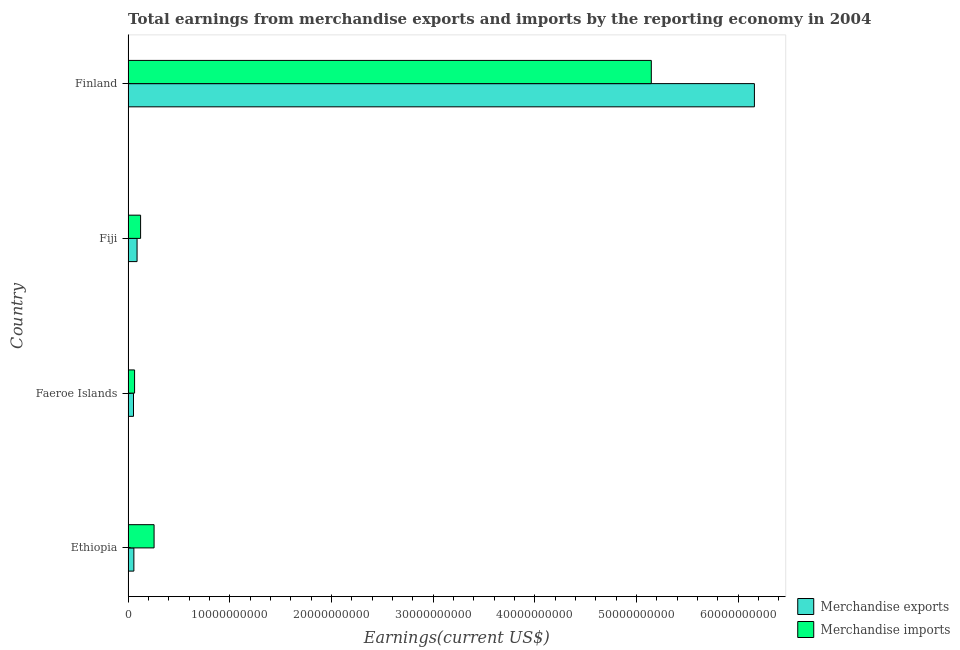How many different coloured bars are there?
Ensure brevity in your answer.  2. Are the number of bars on each tick of the Y-axis equal?
Your answer should be compact. Yes. How many bars are there on the 2nd tick from the top?
Provide a succinct answer. 2. How many bars are there on the 1st tick from the bottom?
Give a very brief answer. 2. What is the label of the 4th group of bars from the top?
Offer a very short reply. Ethiopia. In how many cases, is the number of bars for a given country not equal to the number of legend labels?
Give a very brief answer. 0. What is the earnings from merchandise exports in Faeroe Islands?
Offer a terse response. 5.34e+08. Across all countries, what is the maximum earnings from merchandise exports?
Provide a short and direct response. 6.16e+1. Across all countries, what is the minimum earnings from merchandise exports?
Make the answer very short. 5.34e+08. In which country was the earnings from merchandise exports minimum?
Offer a very short reply. Faeroe Islands. What is the total earnings from merchandise exports in the graph?
Give a very brief answer. 6.36e+1. What is the difference between the earnings from merchandise imports in Fiji and that in Finland?
Offer a terse response. -5.02e+1. What is the difference between the earnings from merchandise exports in Fiji and the earnings from merchandise imports in Faeroe Islands?
Your answer should be compact. 2.45e+08. What is the average earnings from merchandise exports per country?
Offer a very short reply. 1.59e+1. What is the difference between the earnings from merchandise exports and earnings from merchandise imports in Finland?
Ensure brevity in your answer.  1.01e+1. In how many countries, is the earnings from merchandise imports greater than 50000000000 US$?
Give a very brief answer. 1. What is the ratio of the earnings from merchandise imports in Ethiopia to that in Faeroe Islands?
Provide a succinct answer. 4. Is the earnings from merchandise imports in Ethiopia less than that in Fiji?
Your answer should be compact. No. Is the difference between the earnings from merchandise imports in Faeroe Islands and Fiji greater than the difference between the earnings from merchandise exports in Faeroe Islands and Fiji?
Offer a very short reply. No. What is the difference between the highest and the second highest earnings from merchandise imports?
Make the answer very short. 4.89e+1. What is the difference between the highest and the lowest earnings from merchandise imports?
Provide a succinct answer. 5.08e+1. What does the 2nd bar from the top in Ethiopia represents?
Provide a succinct answer. Merchandise exports. What does the 1st bar from the bottom in Finland represents?
Make the answer very short. Merchandise exports. Are all the bars in the graph horizontal?
Offer a very short reply. Yes. How many countries are there in the graph?
Offer a very short reply. 4. Are the values on the major ticks of X-axis written in scientific E-notation?
Offer a very short reply. No. Where does the legend appear in the graph?
Provide a succinct answer. Bottom right. What is the title of the graph?
Your answer should be very brief. Total earnings from merchandise exports and imports by the reporting economy in 2004. Does "Agricultural land" appear as one of the legend labels in the graph?
Your response must be concise. No. What is the label or title of the X-axis?
Give a very brief answer. Earnings(current US$). What is the label or title of the Y-axis?
Provide a short and direct response. Country. What is the Earnings(current US$) of Merchandise exports in Ethiopia?
Ensure brevity in your answer.  5.70e+08. What is the Earnings(current US$) in Merchandise imports in Ethiopia?
Your answer should be very brief. 2.56e+09. What is the Earnings(current US$) in Merchandise exports in Faeroe Islands?
Ensure brevity in your answer.  5.34e+08. What is the Earnings(current US$) of Merchandise imports in Faeroe Islands?
Provide a succinct answer. 6.40e+08. What is the Earnings(current US$) of Merchandise exports in Fiji?
Give a very brief answer. 8.84e+08. What is the Earnings(current US$) in Merchandise imports in Fiji?
Give a very brief answer. 1.23e+09. What is the Earnings(current US$) of Merchandise exports in Finland?
Offer a very short reply. 6.16e+1. What is the Earnings(current US$) of Merchandise imports in Finland?
Your response must be concise. 5.15e+1. Across all countries, what is the maximum Earnings(current US$) of Merchandise exports?
Provide a short and direct response. 6.16e+1. Across all countries, what is the maximum Earnings(current US$) in Merchandise imports?
Give a very brief answer. 5.15e+1. Across all countries, what is the minimum Earnings(current US$) of Merchandise exports?
Keep it short and to the point. 5.34e+08. Across all countries, what is the minimum Earnings(current US$) in Merchandise imports?
Your response must be concise. 6.40e+08. What is the total Earnings(current US$) of Merchandise exports in the graph?
Offer a terse response. 6.36e+1. What is the total Earnings(current US$) of Merchandise imports in the graph?
Offer a very short reply. 5.59e+1. What is the difference between the Earnings(current US$) in Merchandise exports in Ethiopia and that in Faeroe Islands?
Keep it short and to the point. 3.67e+07. What is the difference between the Earnings(current US$) of Merchandise imports in Ethiopia and that in Faeroe Islands?
Your answer should be very brief. 1.92e+09. What is the difference between the Earnings(current US$) of Merchandise exports in Ethiopia and that in Fiji?
Keep it short and to the point. -3.14e+08. What is the difference between the Earnings(current US$) in Merchandise imports in Ethiopia and that in Fiji?
Offer a terse response. 1.33e+09. What is the difference between the Earnings(current US$) in Merchandise exports in Ethiopia and that in Finland?
Provide a short and direct response. -6.10e+1. What is the difference between the Earnings(current US$) of Merchandise imports in Ethiopia and that in Finland?
Your response must be concise. -4.89e+1. What is the difference between the Earnings(current US$) of Merchandise exports in Faeroe Islands and that in Fiji?
Give a very brief answer. -3.51e+08. What is the difference between the Earnings(current US$) in Merchandise imports in Faeroe Islands and that in Fiji?
Keep it short and to the point. -5.92e+08. What is the difference between the Earnings(current US$) of Merchandise exports in Faeroe Islands and that in Finland?
Offer a terse response. -6.11e+1. What is the difference between the Earnings(current US$) of Merchandise imports in Faeroe Islands and that in Finland?
Give a very brief answer. -5.08e+1. What is the difference between the Earnings(current US$) in Merchandise exports in Fiji and that in Finland?
Provide a short and direct response. -6.07e+1. What is the difference between the Earnings(current US$) of Merchandise imports in Fiji and that in Finland?
Give a very brief answer. -5.02e+1. What is the difference between the Earnings(current US$) of Merchandise exports in Ethiopia and the Earnings(current US$) of Merchandise imports in Faeroe Islands?
Your response must be concise. -6.91e+07. What is the difference between the Earnings(current US$) in Merchandise exports in Ethiopia and the Earnings(current US$) in Merchandise imports in Fiji?
Ensure brevity in your answer.  -6.61e+08. What is the difference between the Earnings(current US$) of Merchandise exports in Ethiopia and the Earnings(current US$) of Merchandise imports in Finland?
Make the answer very short. -5.09e+1. What is the difference between the Earnings(current US$) of Merchandise exports in Faeroe Islands and the Earnings(current US$) of Merchandise imports in Fiji?
Give a very brief answer. -6.98e+08. What is the difference between the Earnings(current US$) of Merchandise exports in Faeroe Islands and the Earnings(current US$) of Merchandise imports in Finland?
Provide a short and direct response. -5.09e+1. What is the difference between the Earnings(current US$) in Merchandise exports in Fiji and the Earnings(current US$) in Merchandise imports in Finland?
Your answer should be compact. -5.06e+1. What is the average Earnings(current US$) in Merchandise exports per country?
Keep it short and to the point. 1.59e+1. What is the average Earnings(current US$) of Merchandise imports per country?
Your answer should be very brief. 1.40e+1. What is the difference between the Earnings(current US$) in Merchandise exports and Earnings(current US$) in Merchandise imports in Ethiopia?
Your response must be concise. -1.99e+09. What is the difference between the Earnings(current US$) of Merchandise exports and Earnings(current US$) of Merchandise imports in Faeroe Islands?
Your answer should be very brief. -1.06e+08. What is the difference between the Earnings(current US$) in Merchandise exports and Earnings(current US$) in Merchandise imports in Fiji?
Your answer should be very brief. -3.47e+08. What is the difference between the Earnings(current US$) in Merchandise exports and Earnings(current US$) in Merchandise imports in Finland?
Make the answer very short. 1.01e+1. What is the ratio of the Earnings(current US$) of Merchandise exports in Ethiopia to that in Faeroe Islands?
Provide a short and direct response. 1.07. What is the ratio of the Earnings(current US$) of Merchandise imports in Ethiopia to that in Faeroe Islands?
Provide a short and direct response. 4. What is the ratio of the Earnings(current US$) in Merchandise exports in Ethiopia to that in Fiji?
Keep it short and to the point. 0.65. What is the ratio of the Earnings(current US$) in Merchandise imports in Ethiopia to that in Fiji?
Keep it short and to the point. 2.08. What is the ratio of the Earnings(current US$) of Merchandise exports in Ethiopia to that in Finland?
Your answer should be very brief. 0.01. What is the ratio of the Earnings(current US$) in Merchandise imports in Ethiopia to that in Finland?
Offer a terse response. 0.05. What is the ratio of the Earnings(current US$) in Merchandise exports in Faeroe Islands to that in Fiji?
Your answer should be very brief. 0.6. What is the ratio of the Earnings(current US$) in Merchandise imports in Faeroe Islands to that in Fiji?
Ensure brevity in your answer.  0.52. What is the ratio of the Earnings(current US$) of Merchandise exports in Faeroe Islands to that in Finland?
Your answer should be compact. 0.01. What is the ratio of the Earnings(current US$) in Merchandise imports in Faeroe Islands to that in Finland?
Provide a short and direct response. 0.01. What is the ratio of the Earnings(current US$) in Merchandise exports in Fiji to that in Finland?
Provide a succinct answer. 0.01. What is the ratio of the Earnings(current US$) of Merchandise imports in Fiji to that in Finland?
Your response must be concise. 0.02. What is the difference between the highest and the second highest Earnings(current US$) in Merchandise exports?
Your answer should be compact. 6.07e+1. What is the difference between the highest and the second highest Earnings(current US$) of Merchandise imports?
Keep it short and to the point. 4.89e+1. What is the difference between the highest and the lowest Earnings(current US$) of Merchandise exports?
Keep it short and to the point. 6.11e+1. What is the difference between the highest and the lowest Earnings(current US$) in Merchandise imports?
Provide a succinct answer. 5.08e+1. 